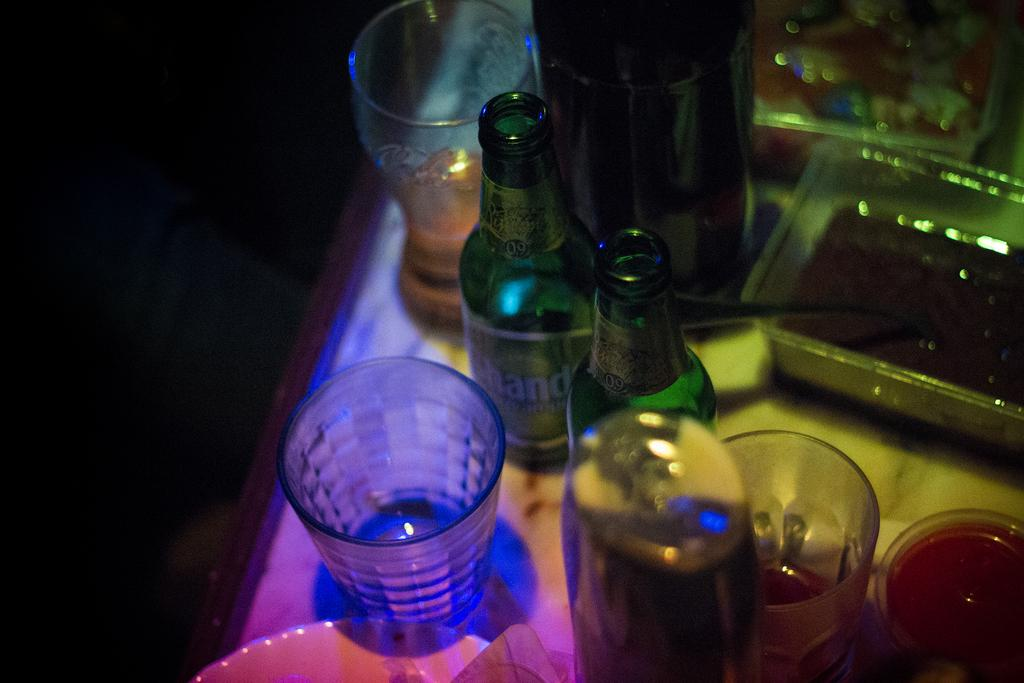<image>
Share a concise interpretation of the image provided. A bottle with the word hand visible on it. 